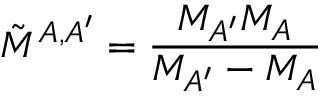<formula> <loc_0><loc_0><loc_500><loc_500>\tilde { M } ^ { A , A ^ { \prime } } = \frac { M _ { A ^ { \prime } } M _ { A } } { M _ { A ^ { \prime } } - M _ { A } }</formula> 